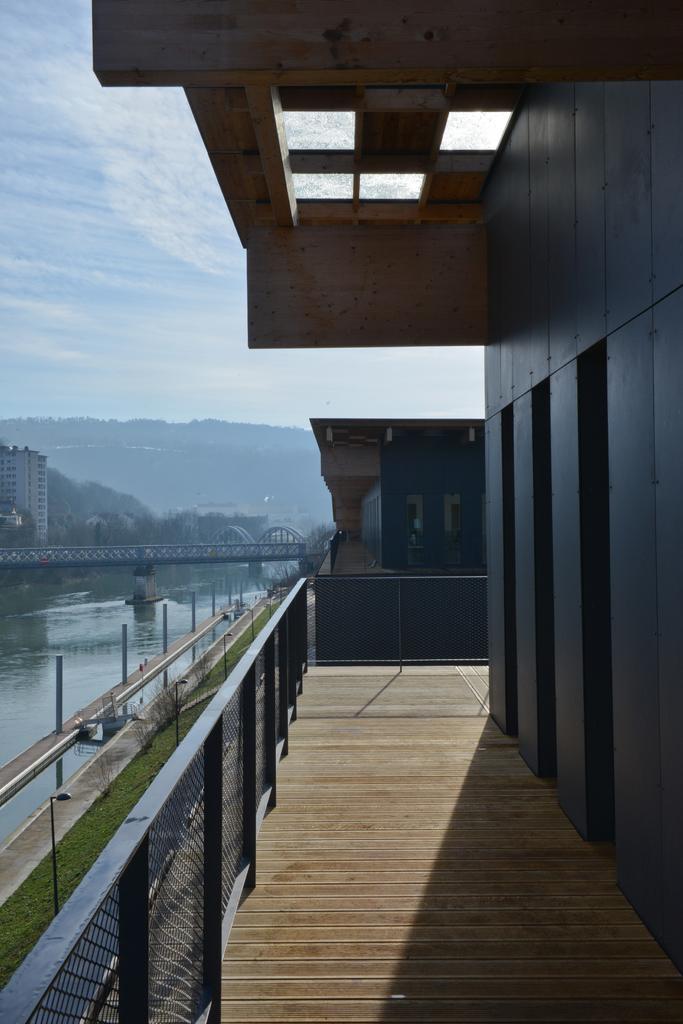Could you give a brief overview of what you see in this image? In this image we can see some buildings, there is a bridge above the water, in the background we can see mountains and sky. 